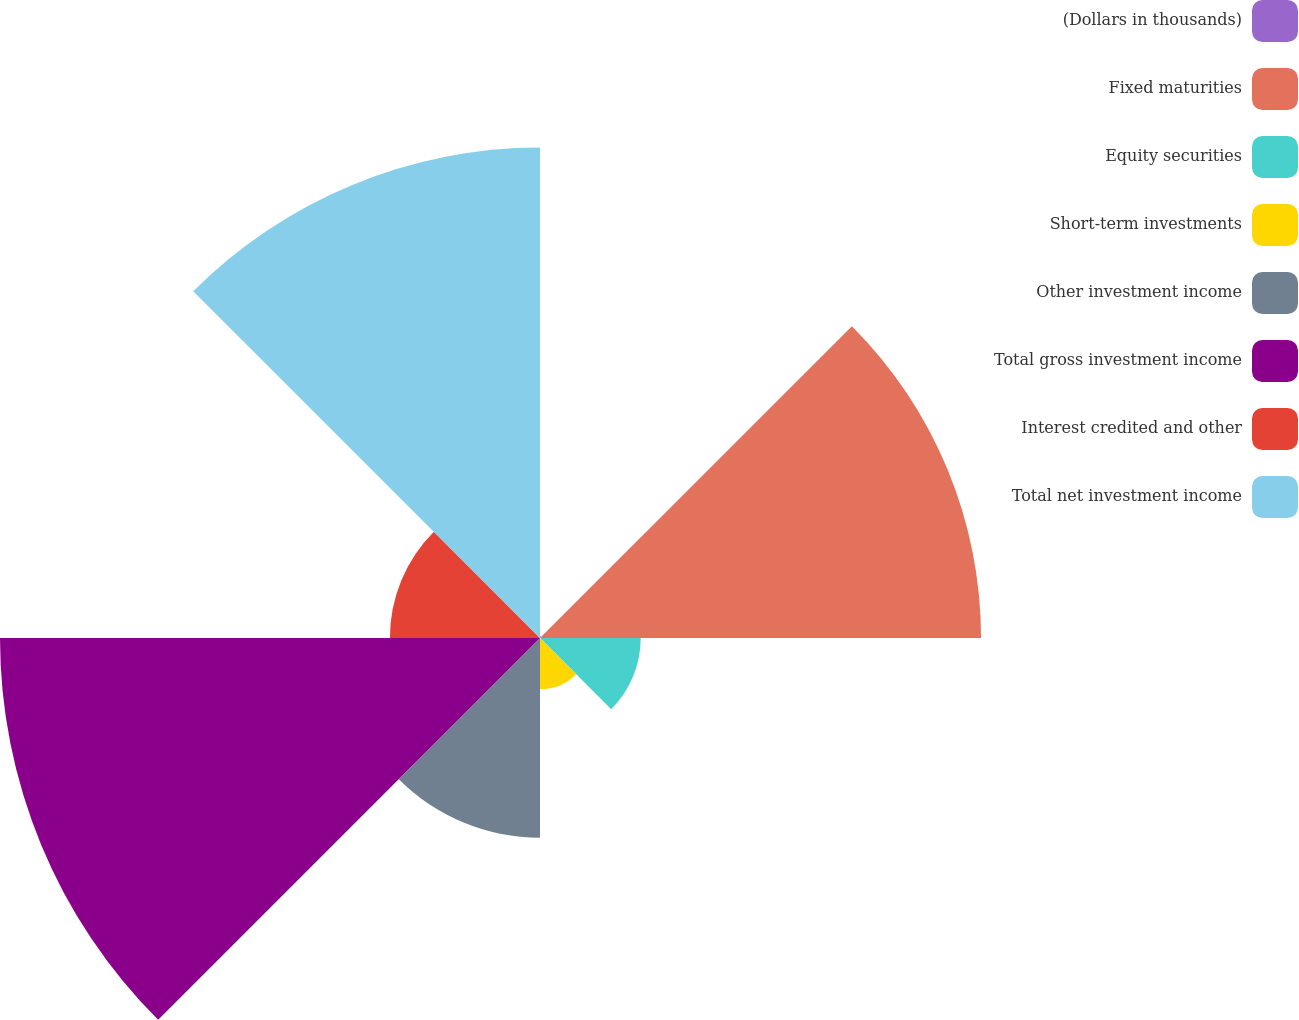Convert chart. <chart><loc_0><loc_0><loc_500><loc_500><pie_chart><fcel>(Dollars in thousands)<fcel>Fixed maturities<fcel>Equity securities<fcel>Short-term investments<fcel>Other investment income<fcel>Total gross investment income<fcel>Interest credited and other<fcel>Total net investment income<nl><fcel>0.09%<fcel>22.33%<fcel>5.1%<fcel>2.6%<fcel>10.11%<fcel>27.34%<fcel>7.6%<fcel>24.83%<nl></chart> 